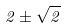Convert formula to latex. <formula><loc_0><loc_0><loc_500><loc_500>2 \pm \sqrt { 2 }</formula> 